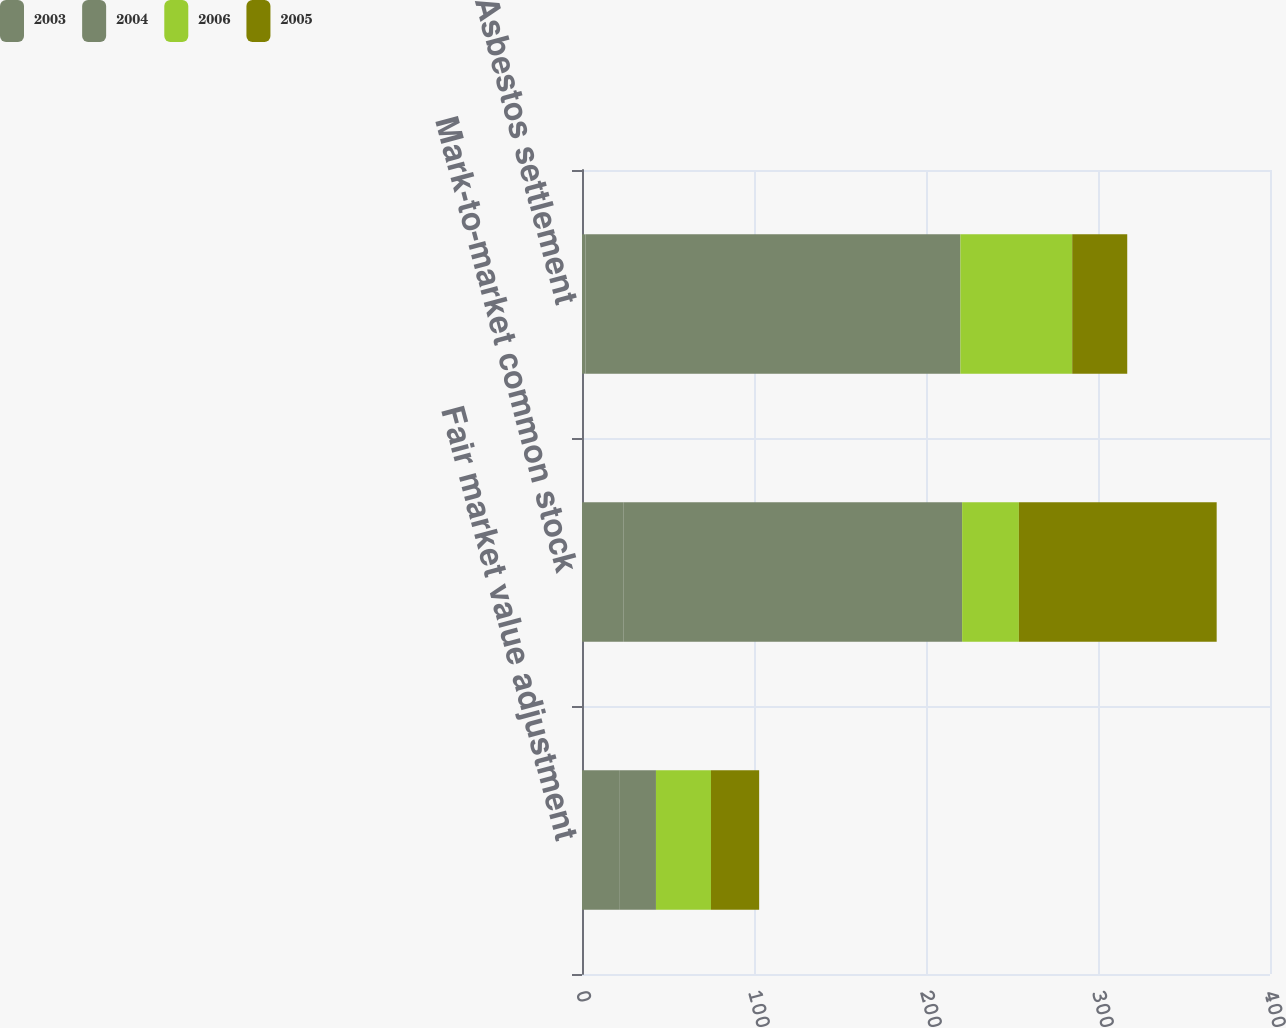Convert chart to OTSL. <chart><loc_0><loc_0><loc_500><loc_500><stacked_bar_chart><ecel><fcel>Fair market value adjustment<fcel>Mark-to-market common stock<fcel>Asbestos settlement<nl><fcel>2003<fcel>22<fcel>24<fcel>2<nl><fcel>2004<fcel>21<fcel>197<fcel>218<nl><fcel>2006<fcel>32<fcel>33<fcel>65<nl><fcel>2005<fcel>28<fcel>115<fcel>32<nl></chart> 